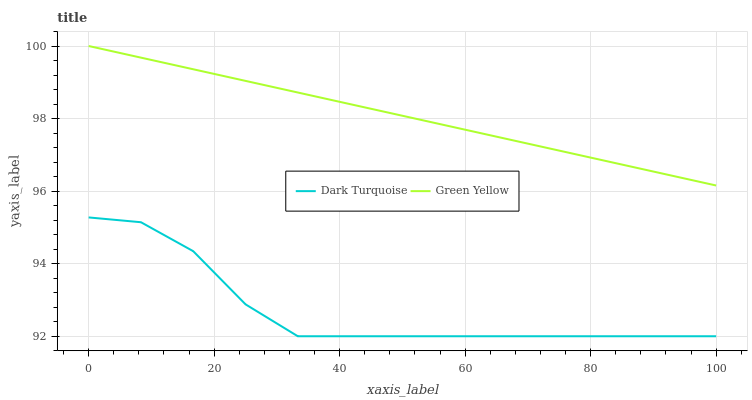Does Dark Turquoise have the minimum area under the curve?
Answer yes or no. Yes. Does Green Yellow have the maximum area under the curve?
Answer yes or no. Yes. Does Green Yellow have the minimum area under the curve?
Answer yes or no. No. Is Green Yellow the smoothest?
Answer yes or no. Yes. Is Dark Turquoise the roughest?
Answer yes or no. Yes. Is Green Yellow the roughest?
Answer yes or no. No. Does Dark Turquoise have the lowest value?
Answer yes or no. Yes. Does Green Yellow have the lowest value?
Answer yes or no. No. Does Green Yellow have the highest value?
Answer yes or no. Yes. Is Dark Turquoise less than Green Yellow?
Answer yes or no. Yes. Is Green Yellow greater than Dark Turquoise?
Answer yes or no. Yes. Does Dark Turquoise intersect Green Yellow?
Answer yes or no. No. 